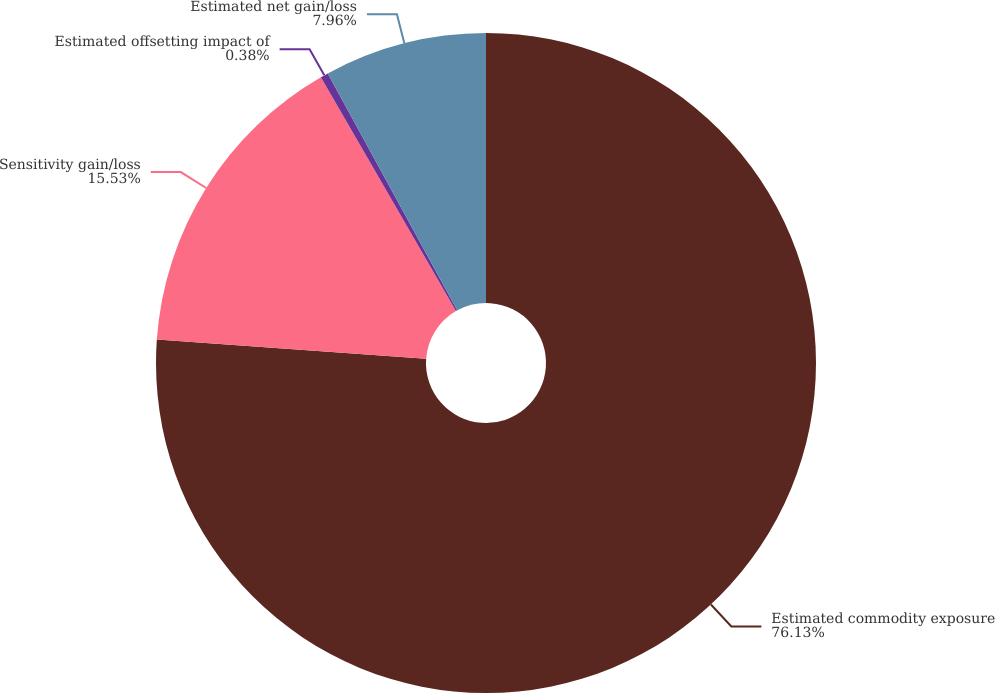Convert chart. <chart><loc_0><loc_0><loc_500><loc_500><pie_chart><fcel>Estimated commodity exposure<fcel>Sensitivity gain/loss<fcel>Estimated offsetting impact of<fcel>Estimated net gain/loss<nl><fcel>76.13%<fcel>15.53%<fcel>0.38%<fcel>7.96%<nl></chart> 